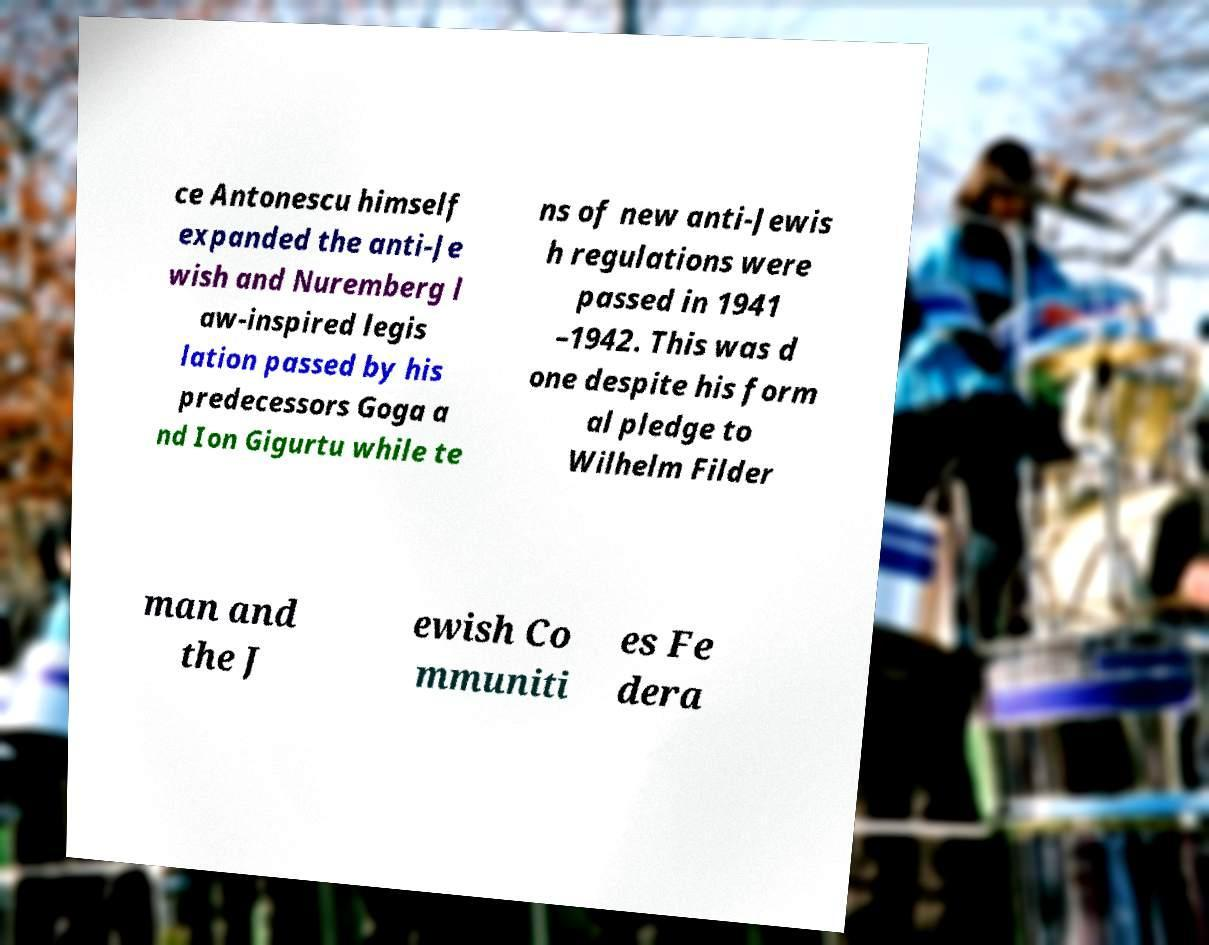I need the written content from this picture converted into text. Can you do that? ce Antonescu himself expanded the anti-Je wish and Nuremberg l aw-inspired legis lation passed by his predecessors Goga a nd Ion Gigurtu while te ns of new anti-Jewis h regulations were passed in 1941 –1942. This was d one despite his form al pledge to Wilhelm Filder man and the J ewish Co mmuniti es Fe dera 